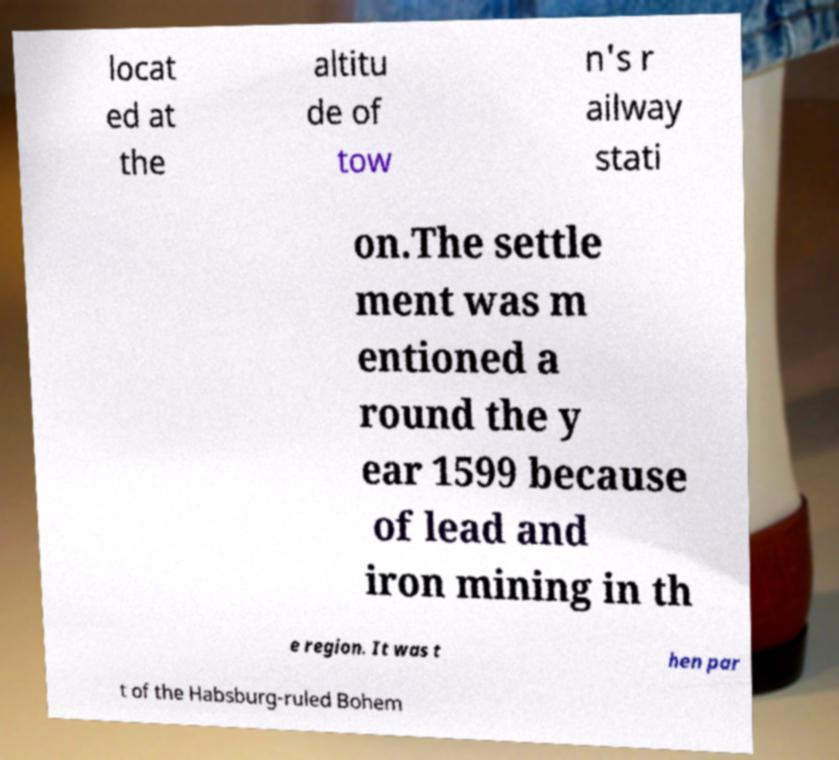For documentation purposes, I need the text within this image transcribed. Could you provide that? locat ed at the altitu de of tow n's r ailway stati on.The settle ment was m entioned a round the y ear 1599 because of lead and iron mining in th e region. It was t hen par t of the Habsburg-ruled Bohem 